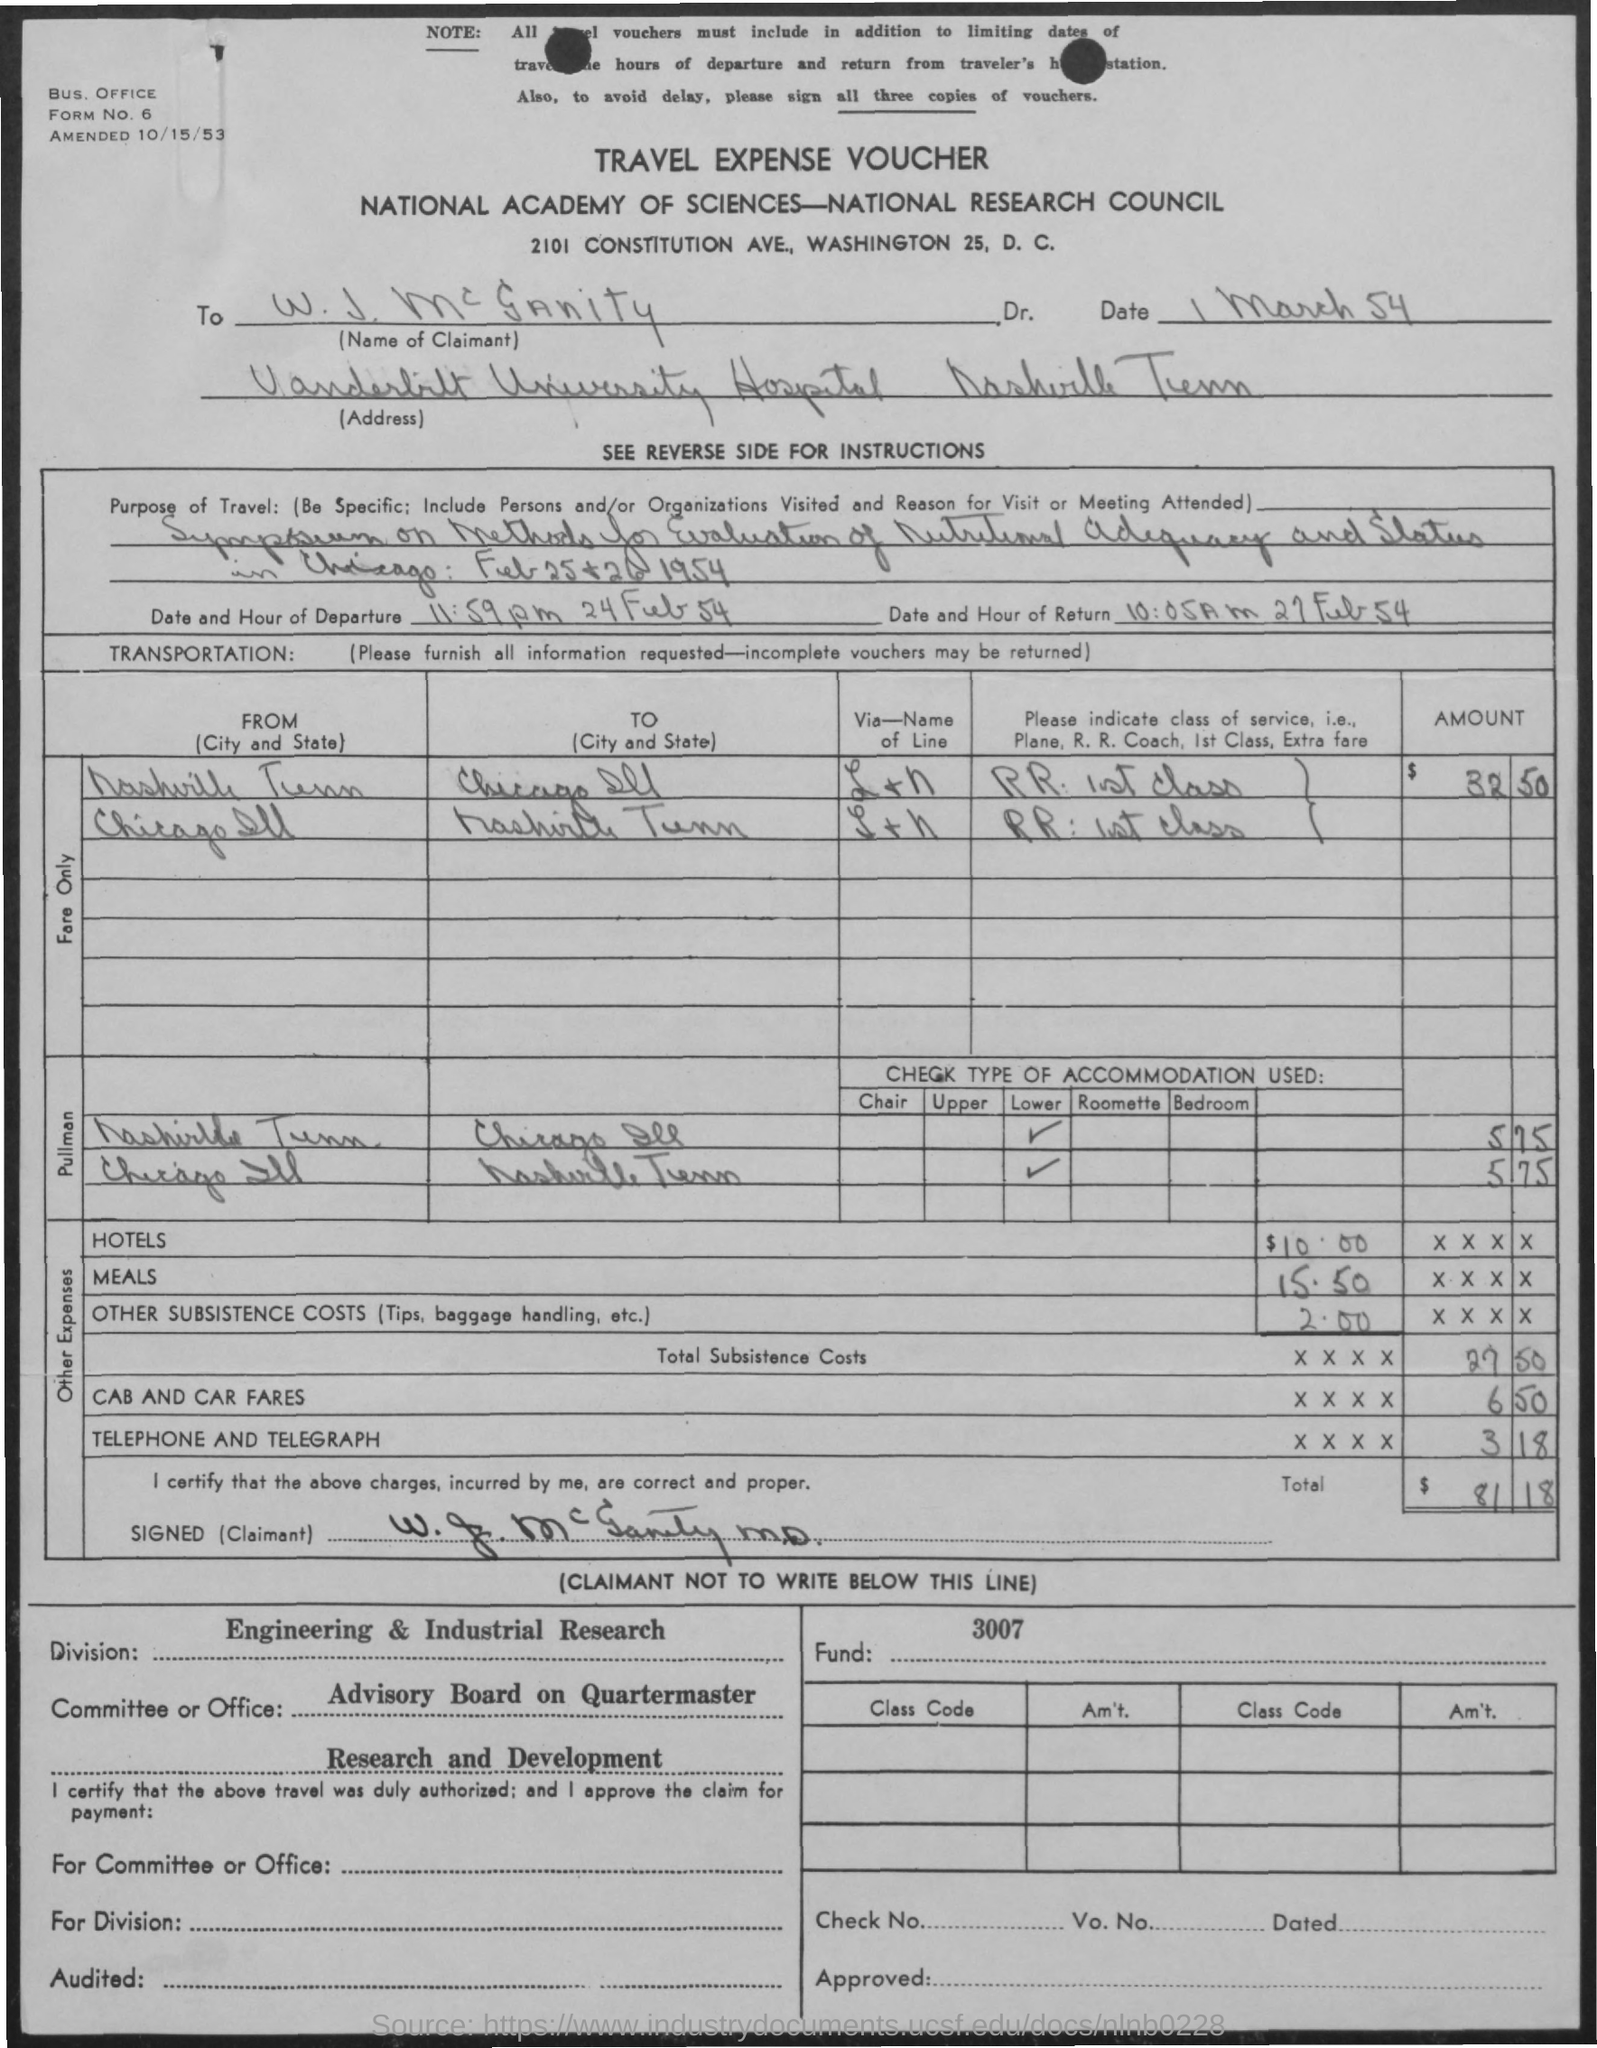Which modes of transportation were used during this travel? During this travel, Dr. McCrannity used railroads, as indicated by the listed 'RR' in the transportation section of the voucher, and specifically 'RR 1st Class,' which suggests that he traveled in the first-class compartment of the train. 